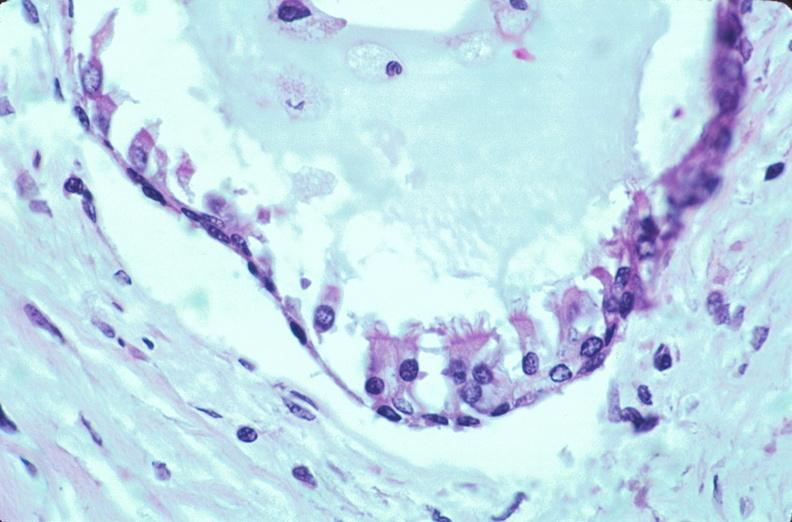s embryo-fetus present?
Answer the question using a single word or phrase. Yes 